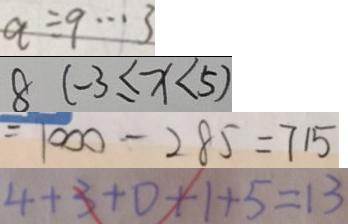Convert formula to latex. <formula><loc_0><loc_0><loc_500><loc_500>q \div 9 \cdots 3 
 8 ( - 3 \leq x < 5 ) 
 = 1 0 0 0 - 2 8 5 = 7 1 5 
 4 + 3 + 0 + 1 + 5 = 1 3</formula> 